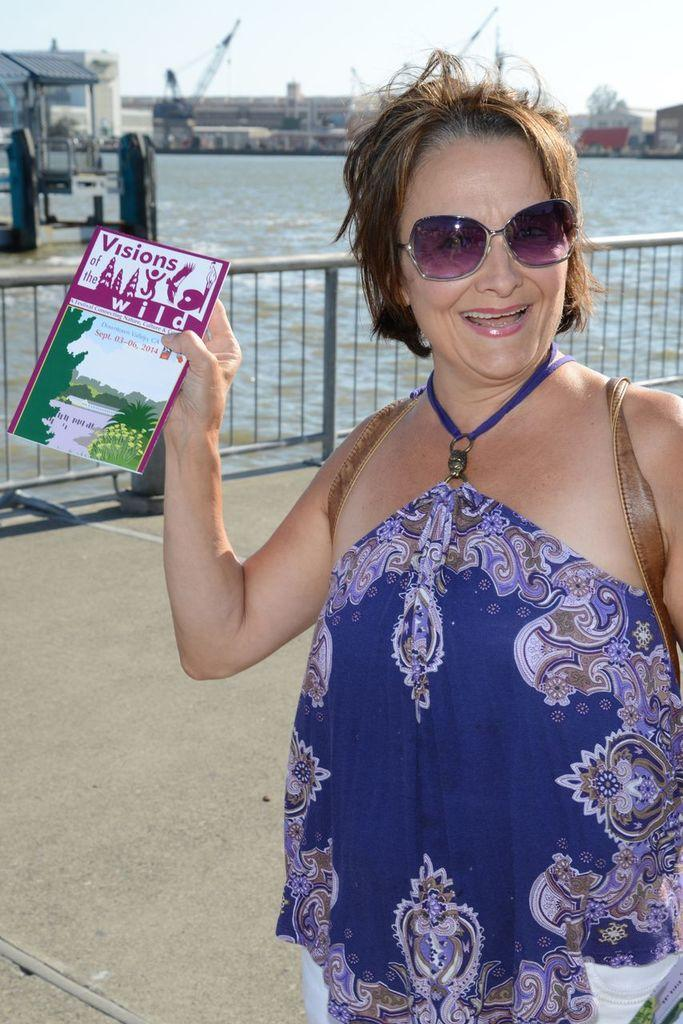What is the lady holding in the image? The lady is holding a poster with text in the image. What can be seen near the lady in the image? There is a railing in the image. What type of structures are visible in the image? There are buildings visible in the image. What natural element is visible in the image? There is water visible in the image. What is visible above the buildings and water in the image? The sky is visible in the image. What color is the kitten playing with the silver worm in the image? There is no kitten or worm present in the image. 